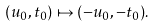<formula> <loc_0><loc_0><loc_500><loc_500>( u _ { 0 } , t _ { 0 } ) \mapsto ( - u _ { 0 } , - t _ { 0 } ) .</formula> 